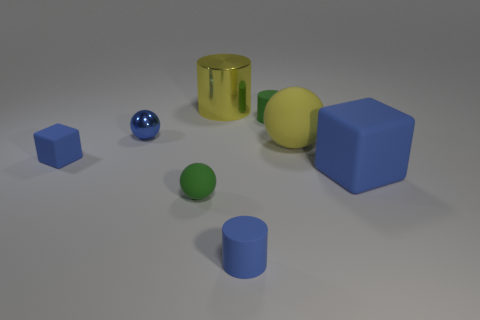How many big matte blocks have the same color as the small shiny object?
Ensure brevity in your answer.  1. There is a cylinder that is the same color as the small rubber ball; what is its material?
Offer a terse response. Rubber. There is a shiny cylinder; is its color the same as the rubber sphere that is behind the tiny matte block?
Give a very brief answer. Yes. How many other things are the same color as the tiny cube?
Provide a succinct answer. 3. There is a green matte cylinder; are there any balls on the right side of it?
Keep it short and to the point. Yes. There is a yellow matte ball; is it the same size as the cube right of the small metallic object?
Keep it short and to the point. Yes. How many other objects are the same material as the green sphere?
Provide a short and direct response. 5. What shape is the thing that is on the right side of the blue matte cylinder and behind the blue sphere?
Your response must be concise. Cylinder. Is the size of the green thing to the right of the yellow metal cylinder the same as the rubber thing that is on the left side of the tiny metallic sphere?
Offer a very short reply. Yes. The green thing that is the same material as the tiny green ball is what shape?
Provide a succinct answer. Cylinder. 